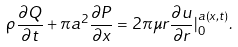<formula> <loc_0><loc_0><loc_500><loc_500>\rho \frac { \partial Q } { \partial t } + \pi a ^ { 2 } \frac { \partial P } { \partial x } = 2 \pi \mu r \frac { \partial u } { \partial r } | _ { 0 } ^ { a \left ( x , t \right ) } .</formula> 